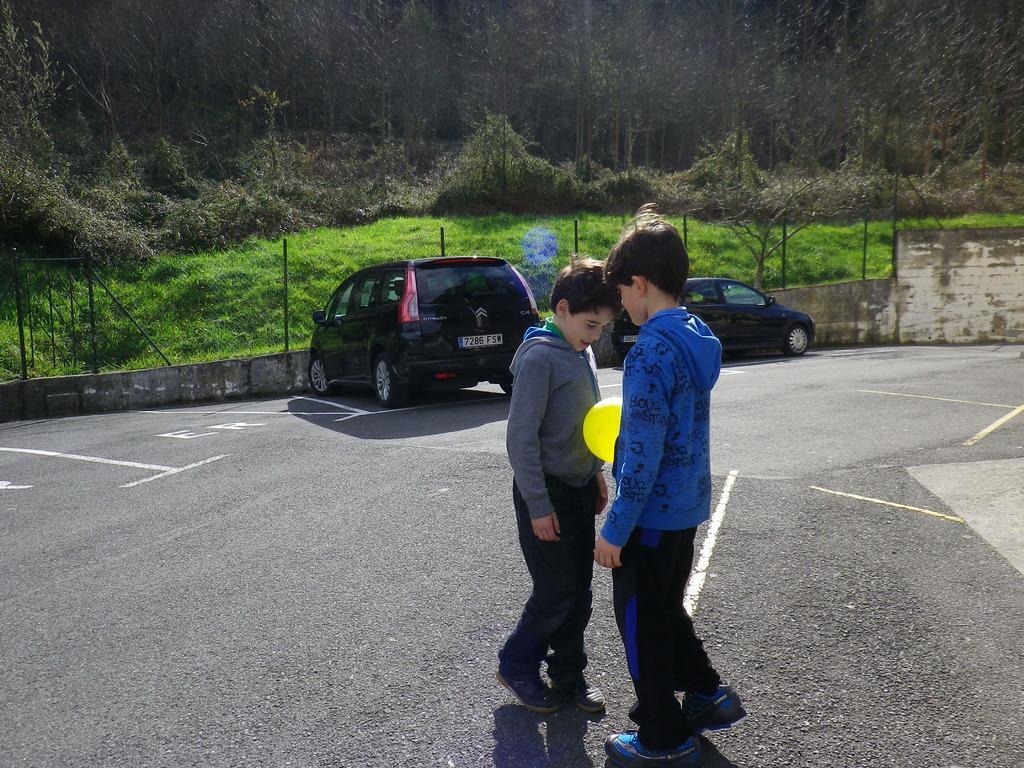In one or two sentences, can you explain what this image depicts? In this picture we can see two boys on the road, and we can find a ball between them, in the background we can see couple of cars, fence, metal rods and trees. 